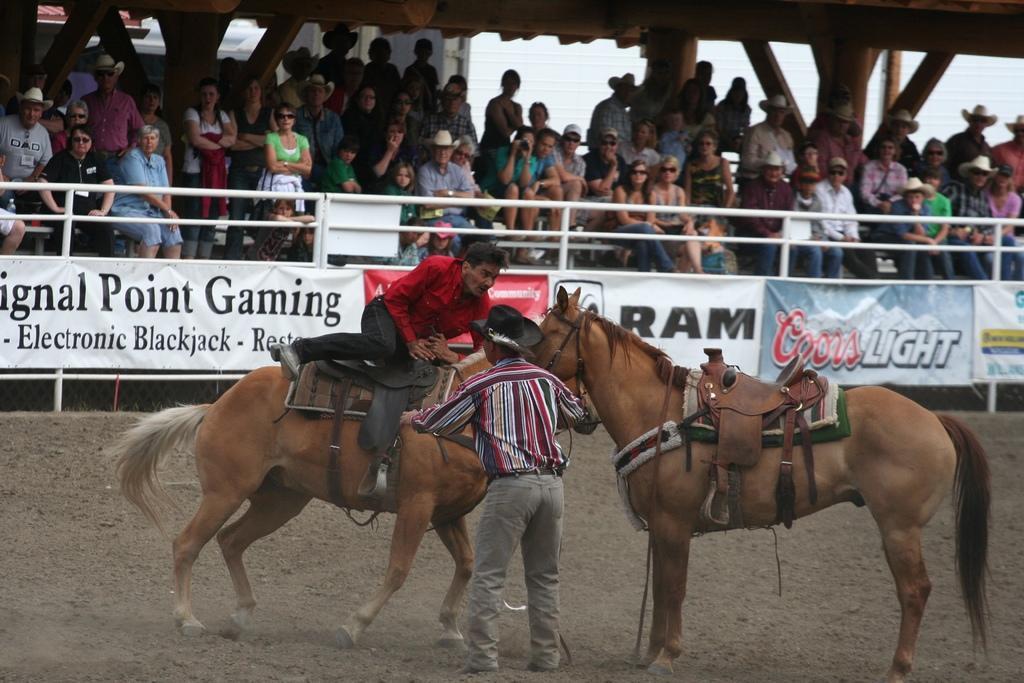In one or two sentences, can you explain what this image depicts? In this image I can see two horses and a person sitting on the horse and a person standing in front of the horse. In the background I can see group of persons sitting on chairs, in front of them I can see a fence. 